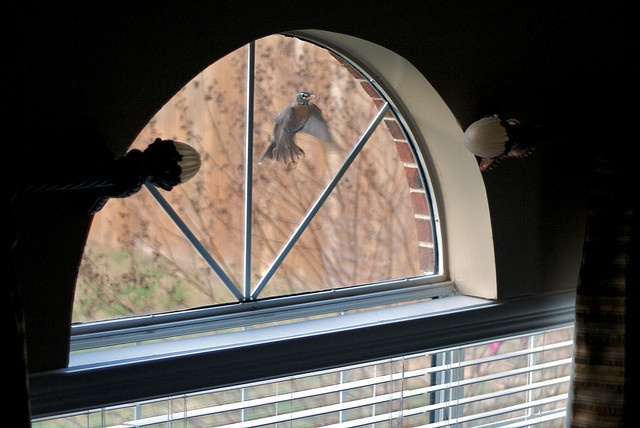Describe the objects in this image and their specific colors. I can see a bird in black, gray, and darkgray tones in this image. 